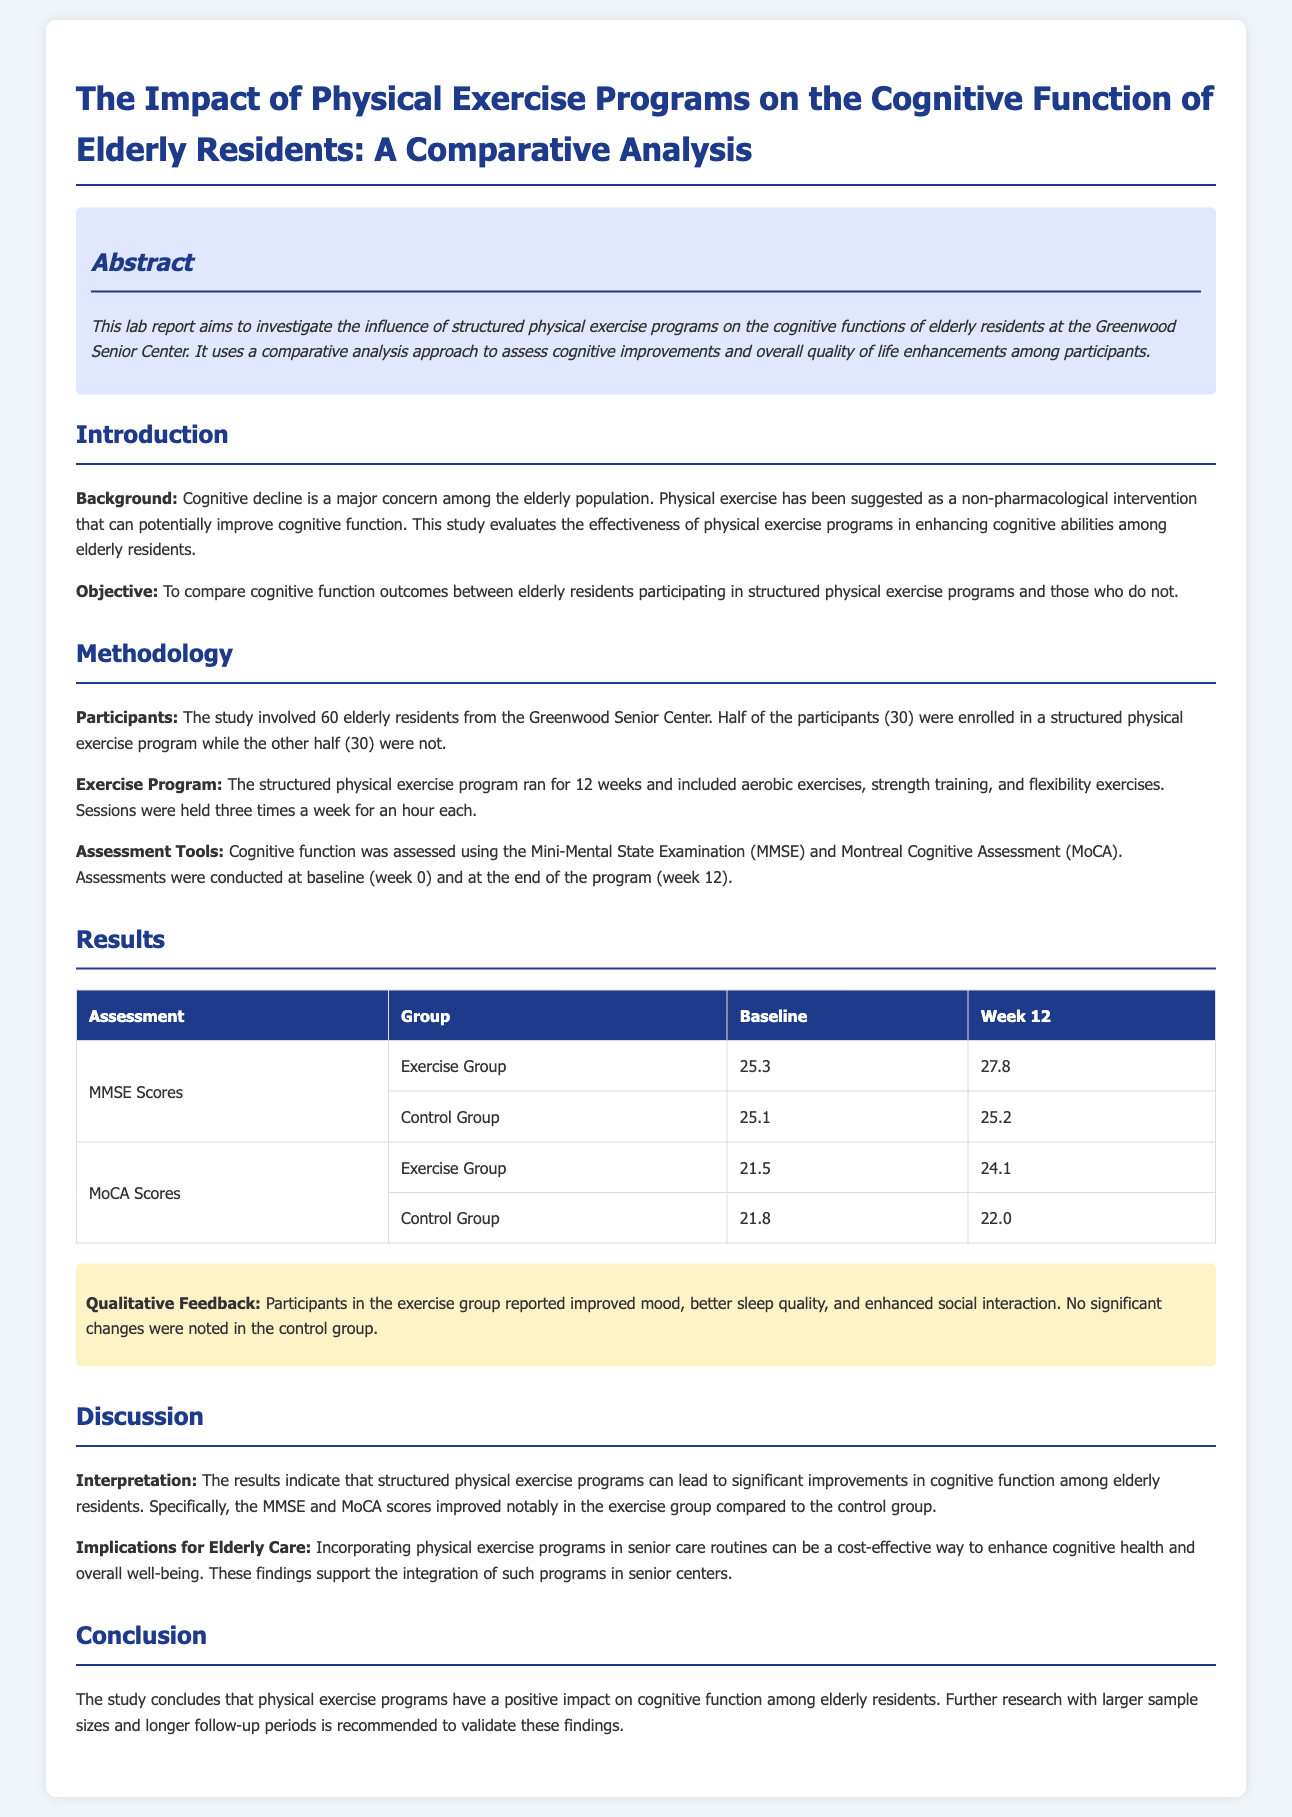What is the main subject of the lab report? The main subject of the lab report is the impact of physical exercise programs on cognitive function in elderly residents.
Answer: The impact of physical exercise programs on cognitive function How many participants were enrolled in the study? The study involved a total of 60 elderly residents.
Answer: 60 What exercise program duration was used in the study? The structured physical exercise program ran for a total of 12 weeks.
Answer: 12 weeks What assessment tools were used to measure cognitive function? Cognitive function was assessed using the Mini-Mental State Examination (MMSE) and the Montreal Cognitive Assessment (MoCA).
Answer: Mini-Mental State Examination and Montreal Cognitive Assessment What was the MMSE score for the exercise group at week 12? The MMSE score for the exercise group at week 12 was 27.8.
Answer: 27.8 What qualitative feedback did participants in the exercise group report? Participants in the exercise group reported improved mood, better sleep quality, and enhanced social interaction.
Answer: Improved mood, better sleep quality, enhanced social interaction What conclusion does the study draw about physical exercise programs? The study concludes that physical exercise programs have a positive impact on cognitive function among elderly residents.
Answer: Positive impact on cognitive function What is recommended for future research according to the study? The study recommends further research with larger sample sizes and longer follow-up periods.
Answer: Larger sample sizes and longer follow-up periods 